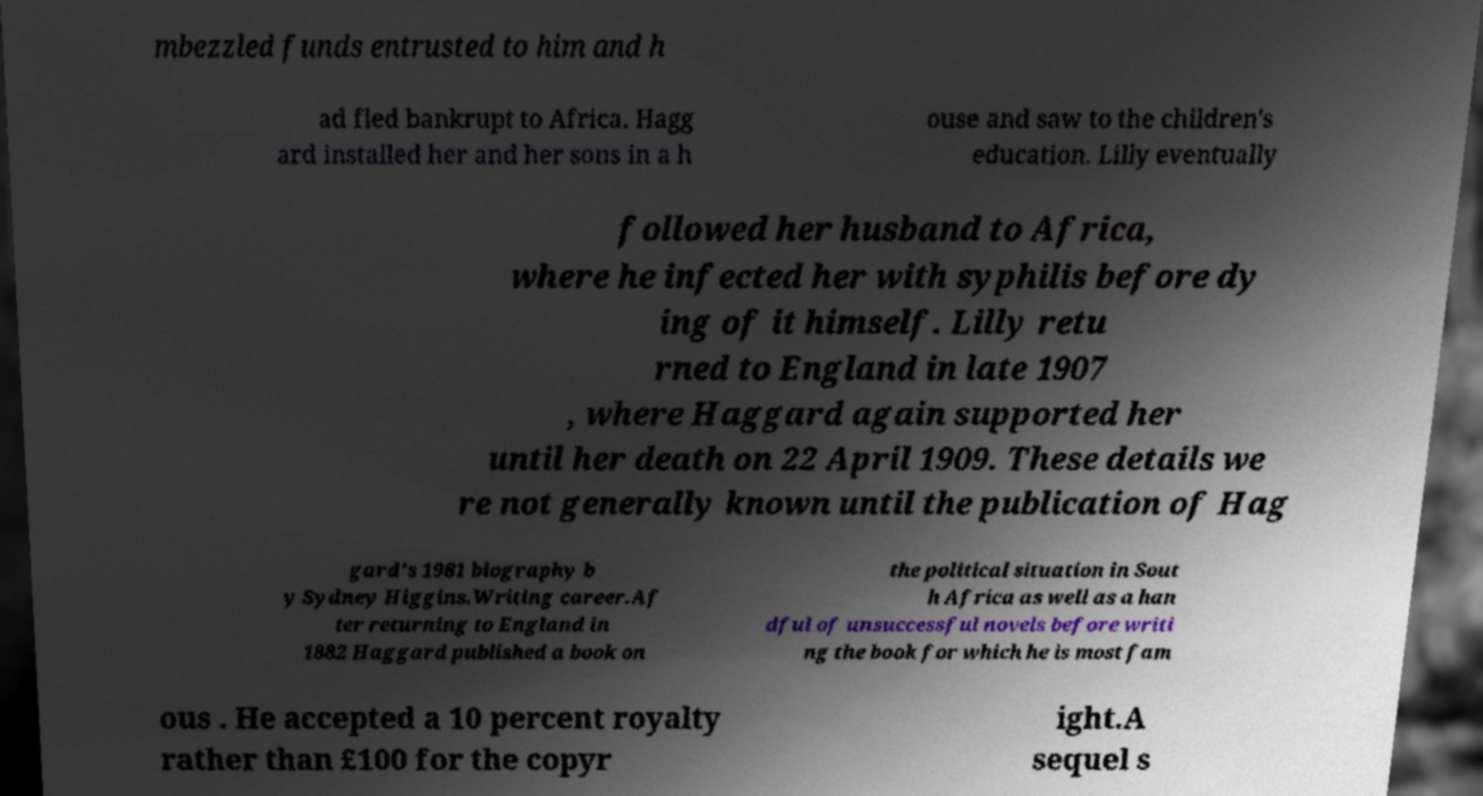Please read and relay the text visible in this image. What does it say? mbezzled funds entrusted to him and h ad fled bankrupt to Africa. Hagg ard installed her and her sons in a h ouse and saw to the children's education. Lilly eventually followed her husband to Africa, where he infected her with syphilis before dy ing of it himself. Lilly retu rned to England in late 1907 , where Haggard again supported her until her death on 22 April 1909. These details we re not generally known until the publication of Hag gard's 1981 biography b y Sydney Higgins.Writing career.Af ter returning to England in 1882 Haggard published a book on the political situation in Sout h Africa as well as a han dful of unsuccessful novels before writi ng the book for which he is most fam ous . He accepted a 10 percent royalty rather than £100 for the copyr ight.A sequel s 